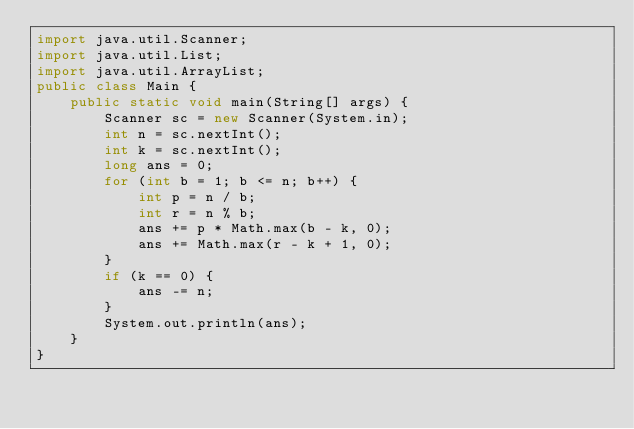Convert code to text. <code><loc_0><loc_0><loc_500><loc_500><_Java_>import java.util.Scanner;
import java.util.List;
import java.util.ArrayList;
public class Main {
    public static void main(String[] args) {
        Scanner sc = new Scanner(System.in);
        int n = sc.nextInt();
        int k = sc.nextInt();
        long ans = 0;
        for (int b = 1; b <= n; b++) {
            int p = n / b;
            int r = n % b;
            ans += p * Math.max(b - k, 0);
            ans += Math.max(r - k + 1, 0);
        }
        if (k == 0) {
            ans -= n;
        }
        System.out.println(ans);
    }
}
</code> 